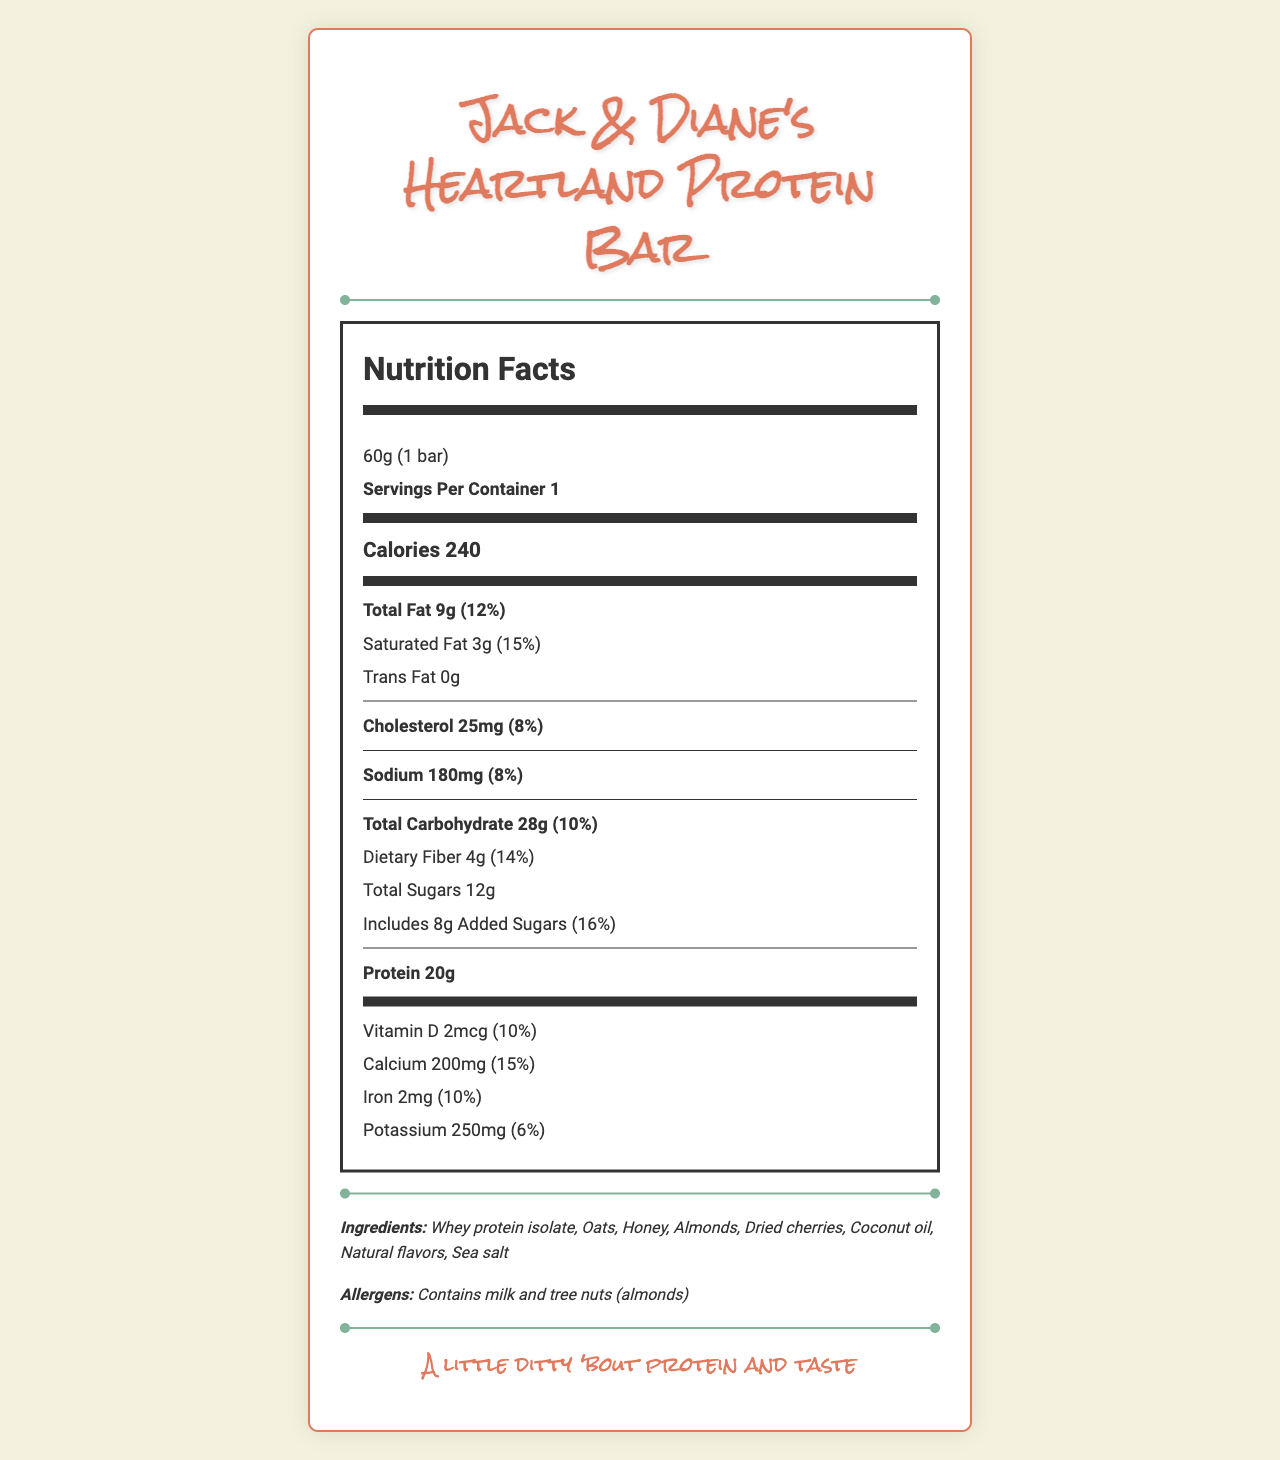what is the serving size of Jack & Diane's Heartland Protein Bar? The serving size is clearly stated as "60g (1 bar)" at the top of the Nutrition Facts section.
Answer: 60g (1 bar) How many calories are there per serving? The Calories section lists 240 calories per serving.
Answer: 240 How much sodium is in the bar? The sodium content is listed as 180mg.
Answer: 180mg What percentage of the daily value of calcium does this protein bar provide? The daily value percentage for calcium is shown as 15%.
Answer: 15% How much protein does the bar contain? The protein content is listed as 20g.
Answer: 20g What are the main allergens in the protein bar? A. Peanuts and soy B. Milk and tree nuts (almonds) C. Wheat and eggs D. Fish and shellfish The allergens listed are milk and tree nuts (almonds).
Answer: B How much added sugar is included in the protein bar? A. 10g B. 0g C. 8g D. 5g The amount of added sugars is listed as 8g.
Answer: C Does this protein bar contain any trans fat? Yes or No The label lists "Trans Fat 0g", indicating there is no trans fat.
Answer: No Summarize the key nutrition and design elements of Jack & Diane's Heartland Protein Bar. This summary captures the key nutritional information and the unique design elements inspired by John Mellencamp.
Answer: The protein bar has 240 calories per serving, contains 20g of protein, and has 12% daily value of total fat. It includes 180mg of sodium and 28g of total carbohydrates. The bar features guitar string-shaped protein crisp pieces and vintage diner artwork, and it includes ingredients like whey protein isolate, oats, honey, and almonds. It contains milk and tree nuts (almonds) as allergens. What flavor profile does Jack & Diane's Heartland Protein Bar have? The document mentions that the flavor profile is inspired by classic American heartland cuisine.
Answer: Classic American heartland cuisine Is the marketing tagline "Fuel your rock 'n' roll dreams" associated with the protein bar? The tagline "Fuel your rock 'n' roll dreams" is one of the marketing taglines listed for the protein bar.
Answer: Yes What are the vitamin D and iron contents in the bar? The label lists Vitamin D as 2mcg with 10% daily value and Iron as 2mg with 10% daily value.
Answer: Vitamin D: 2mcg (10% DV), Iron: 2mg (10% DV) What are the ingredients of the protein bar? The ingredients are listed as a combination of whey protein isolate, oats, honey, almonds, dried cherries, coconut oil, natural flavors, and sea salt.
Answer: Whey protein isolate, Oats, Honey, Almonds, Dried cherries, Coconut oil, Natural flavors, Sea salt How many servings per container are there? The document states that there is only 1 serving per container.
Answer: 1 What is the expiration date of the protein bar? The expiration date is not provided in the document.
Answer: Cannot be determined 